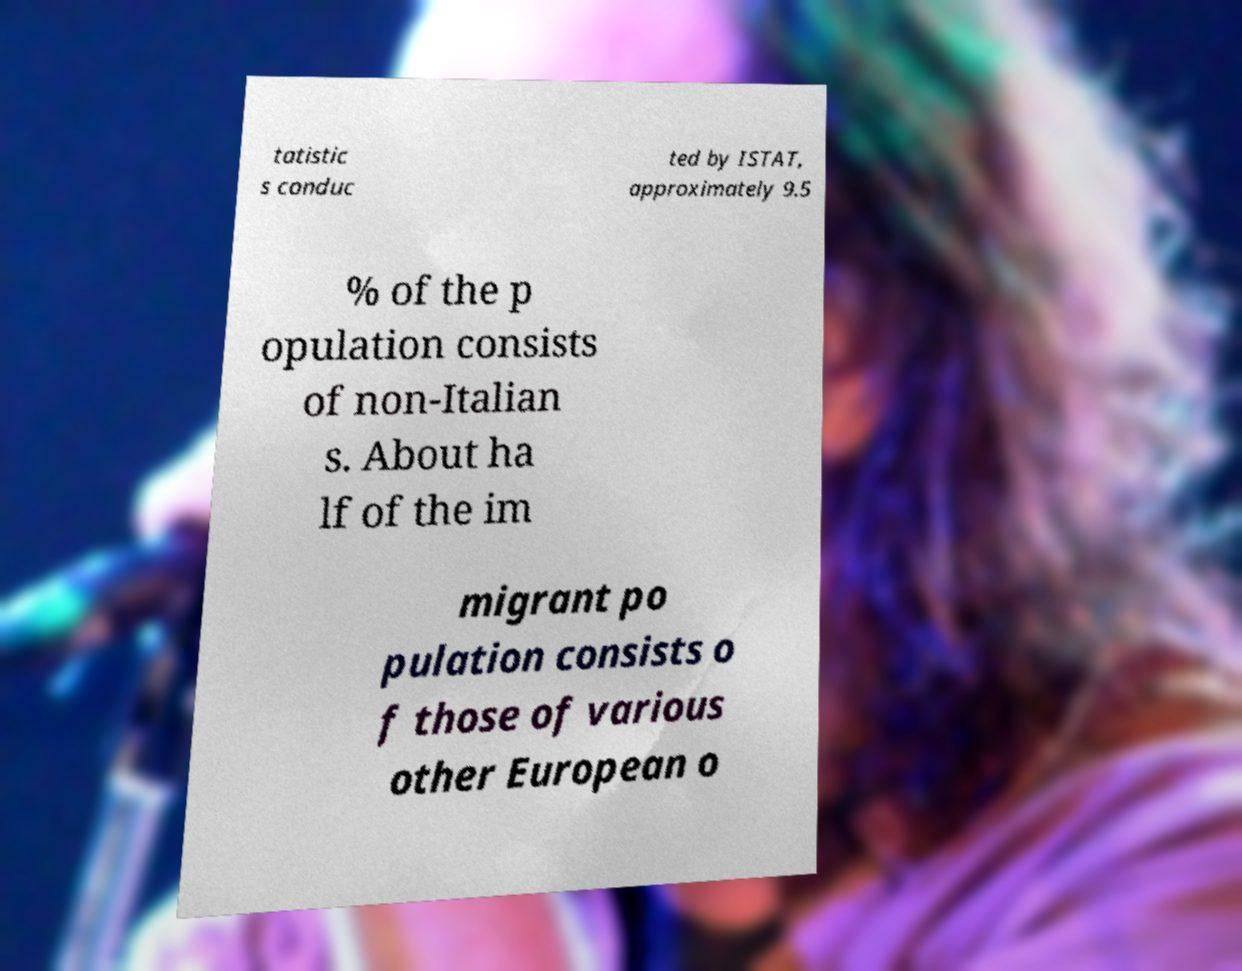Please identify and transcribe the text found in this image. tatistic s conduc ted by ISTAT, approximately 9.5 % of the p opulation consists of non-Italian s. About ha lf of the im migrant po pulation consists o f those of various other European o 